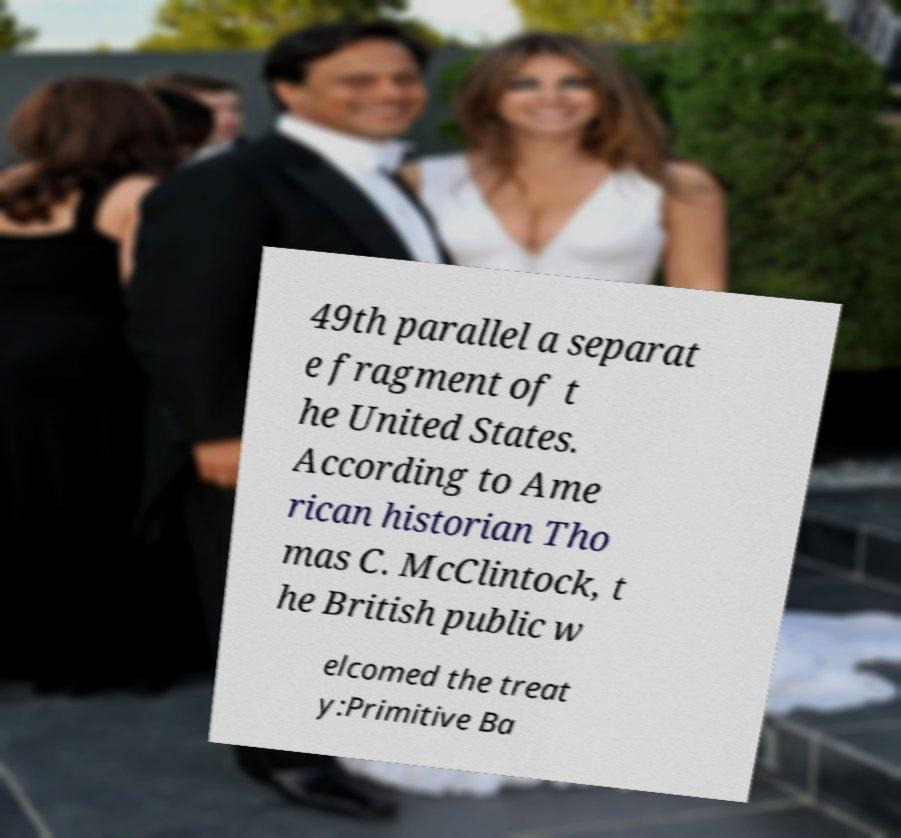For documentation purposes, I need the text within this image transcribed. Could you provide that? 49th parallel a separat e fragment of t he United States. According to Ame rican historian Tho mas C. McClintock, t he British public w elcomed the treat y:Primitive Ba 